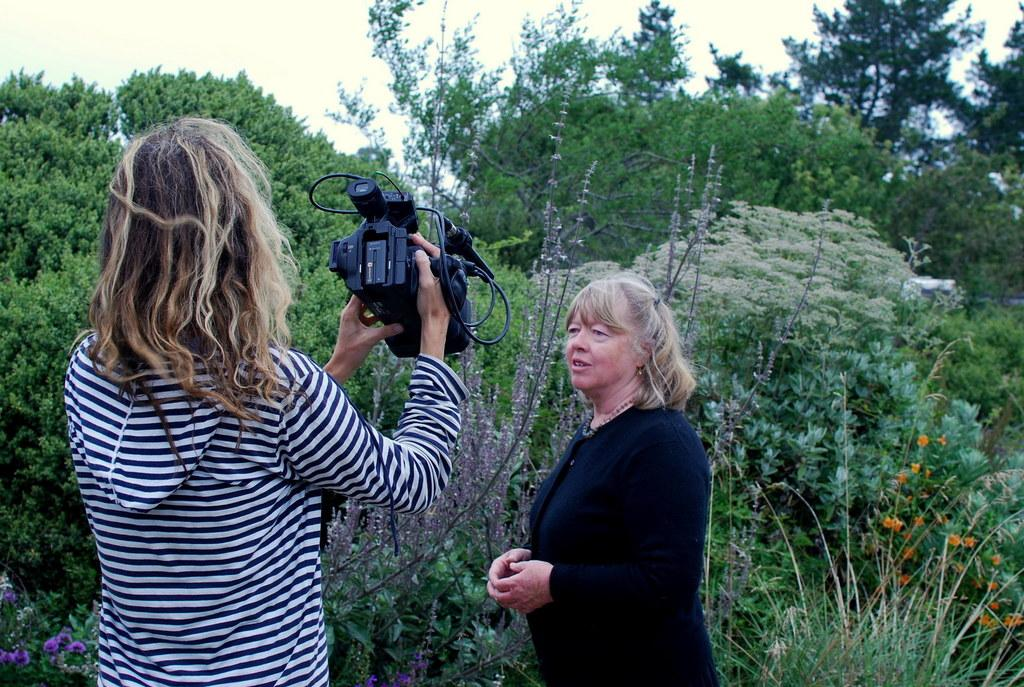What is the woman holding in the image? The woman is holding a camera. What is the woman's posture in the image? The woman is standing. What type of clothing is the woman wearing in the image? The woman is wearing a jacket. What type of vegetation can be seen in the image? There are trees and plants in the image. What type of tub is visible in the image? There is no tub present in the image. What is the woman's experience with photography, as indicated by the image? The image does not provide any information about the woman's experience with photography. 